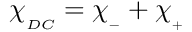<formula> <loc_0><loc_0><loc_500><loc_500>\chi _ { _ { D C } } = \chi _ { _ { - } } + \chi _ { _ { + } }</formula> 